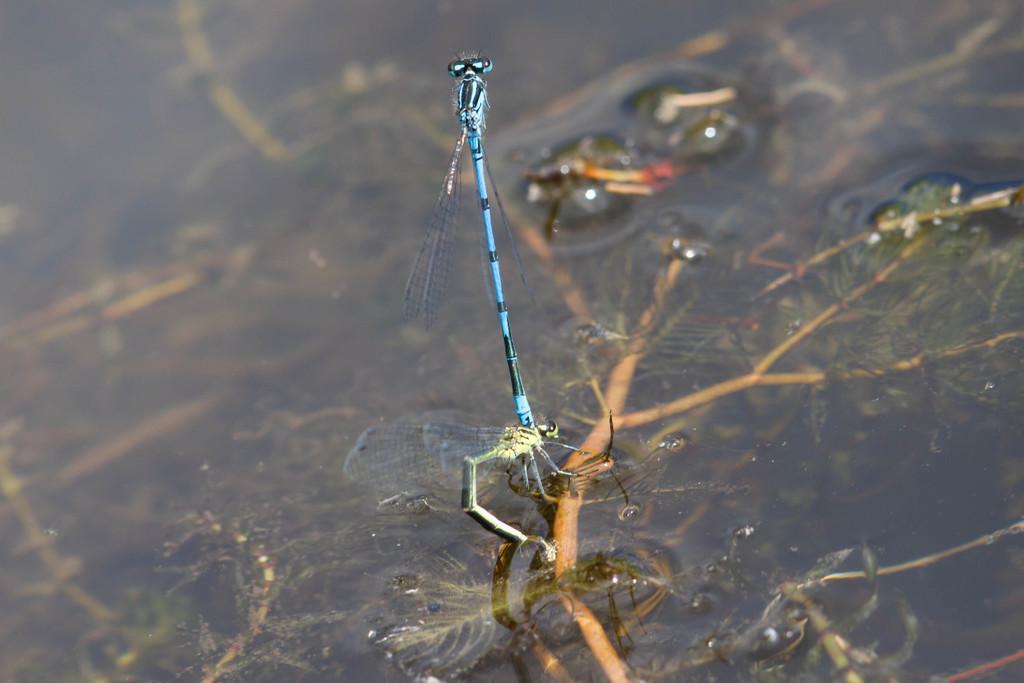Describe this image in one or two sentences. In this image there are insects, water, branches and leaves. 